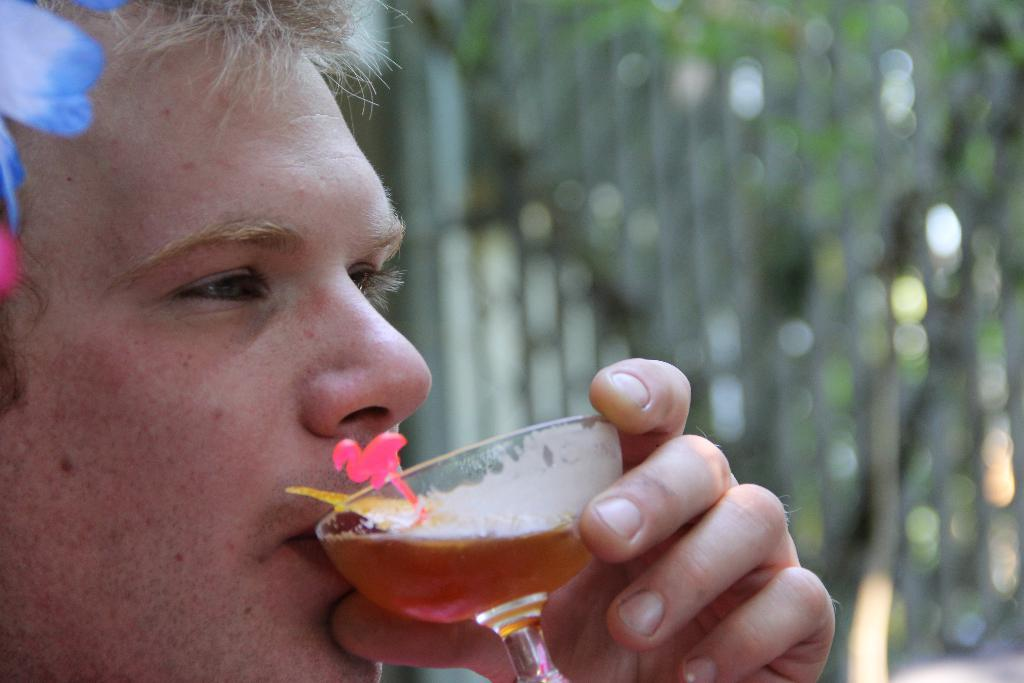Who is the main subject in the image? There is a man in the image. What is the man doing in the image? The man is drinking beer. What can be seen in the background of the image? There are trees in the background of the image. What type of pipe is the man smoking in the image? There is no pipe present in the image; the man is drinking beer. 